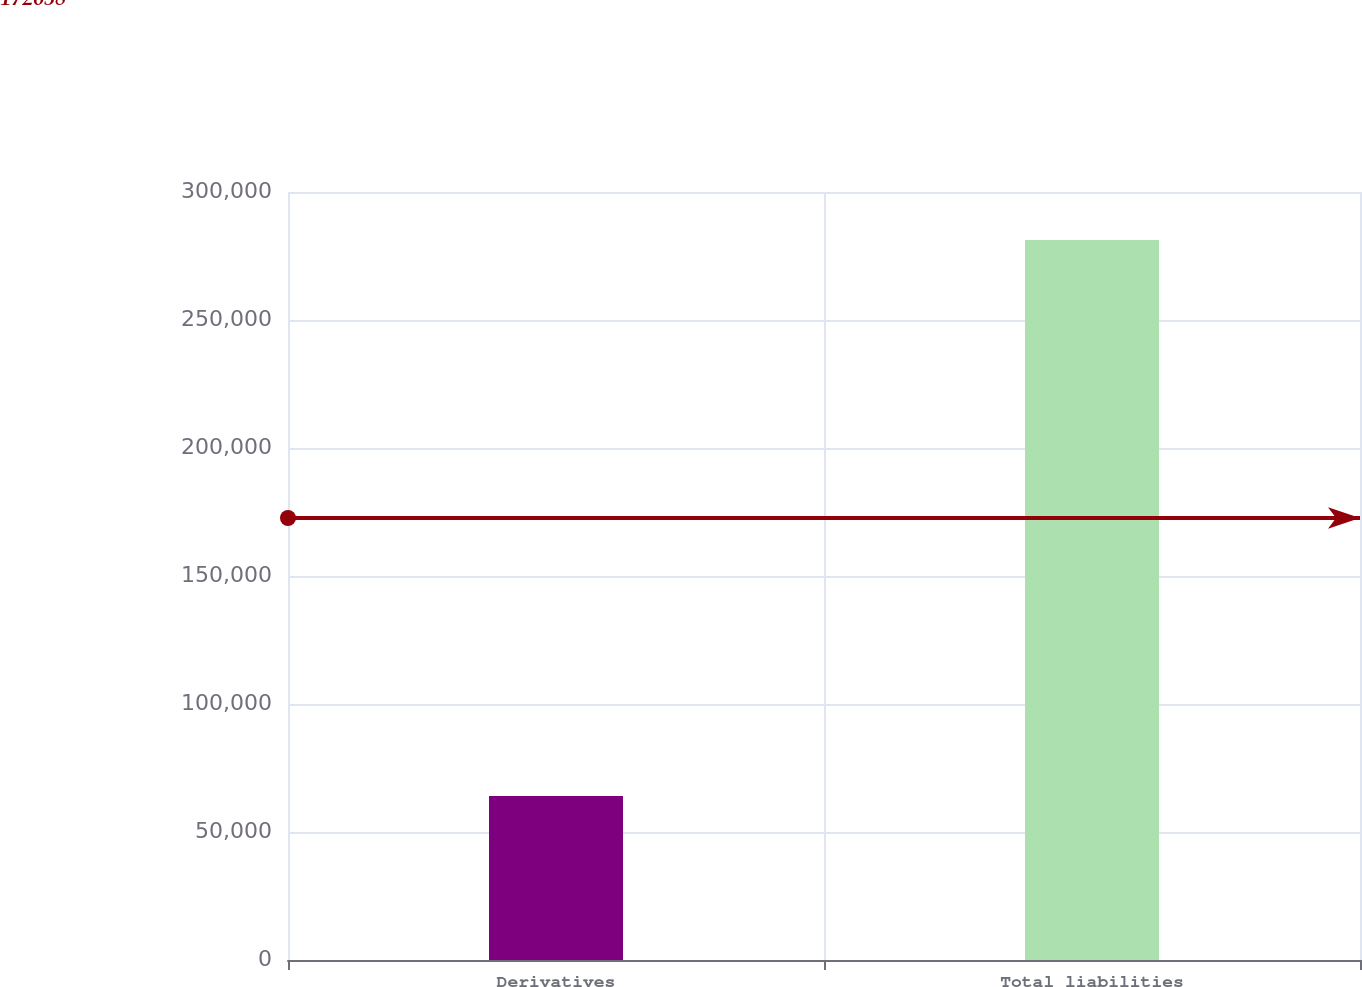Convert chart to OTSL. <chart><loc_0><loc_0><loc_500><loc_500><bar_chart><fcel>Derivatives<fcel>Total liabilities<nl><fcel>64106<fcel>281210<nl></chart> 